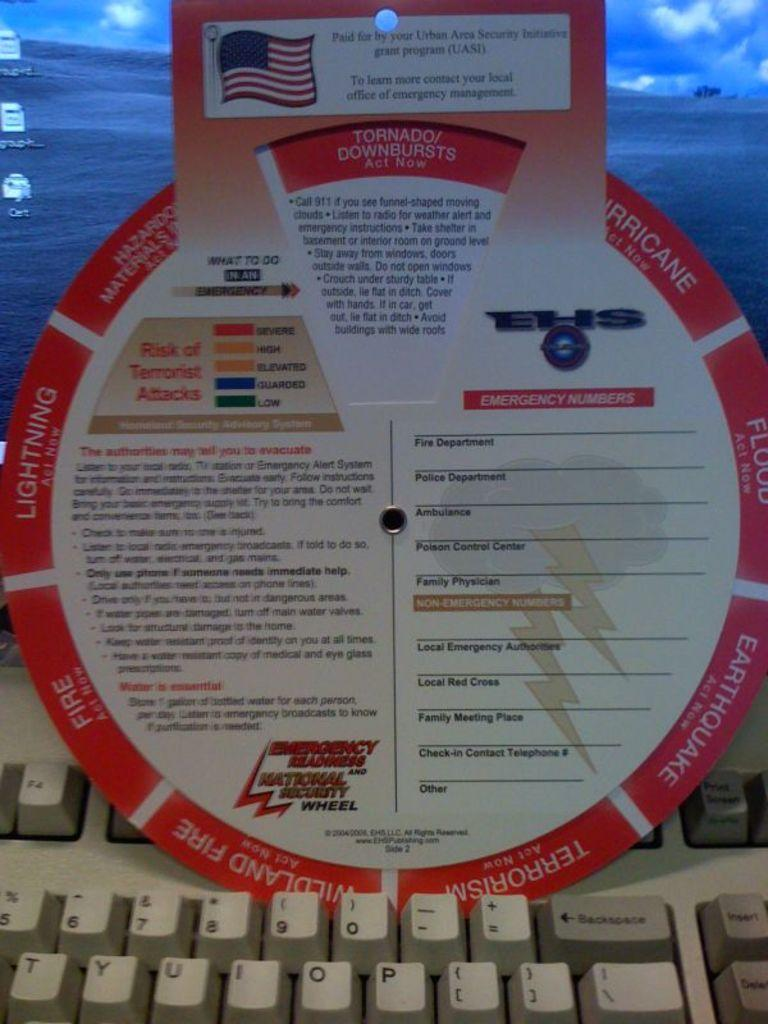<image>
Render a clear and concise summary of the photo. A listing of information put out by the Urban Areas Security Initiative explaining how to survive various emergencies. 